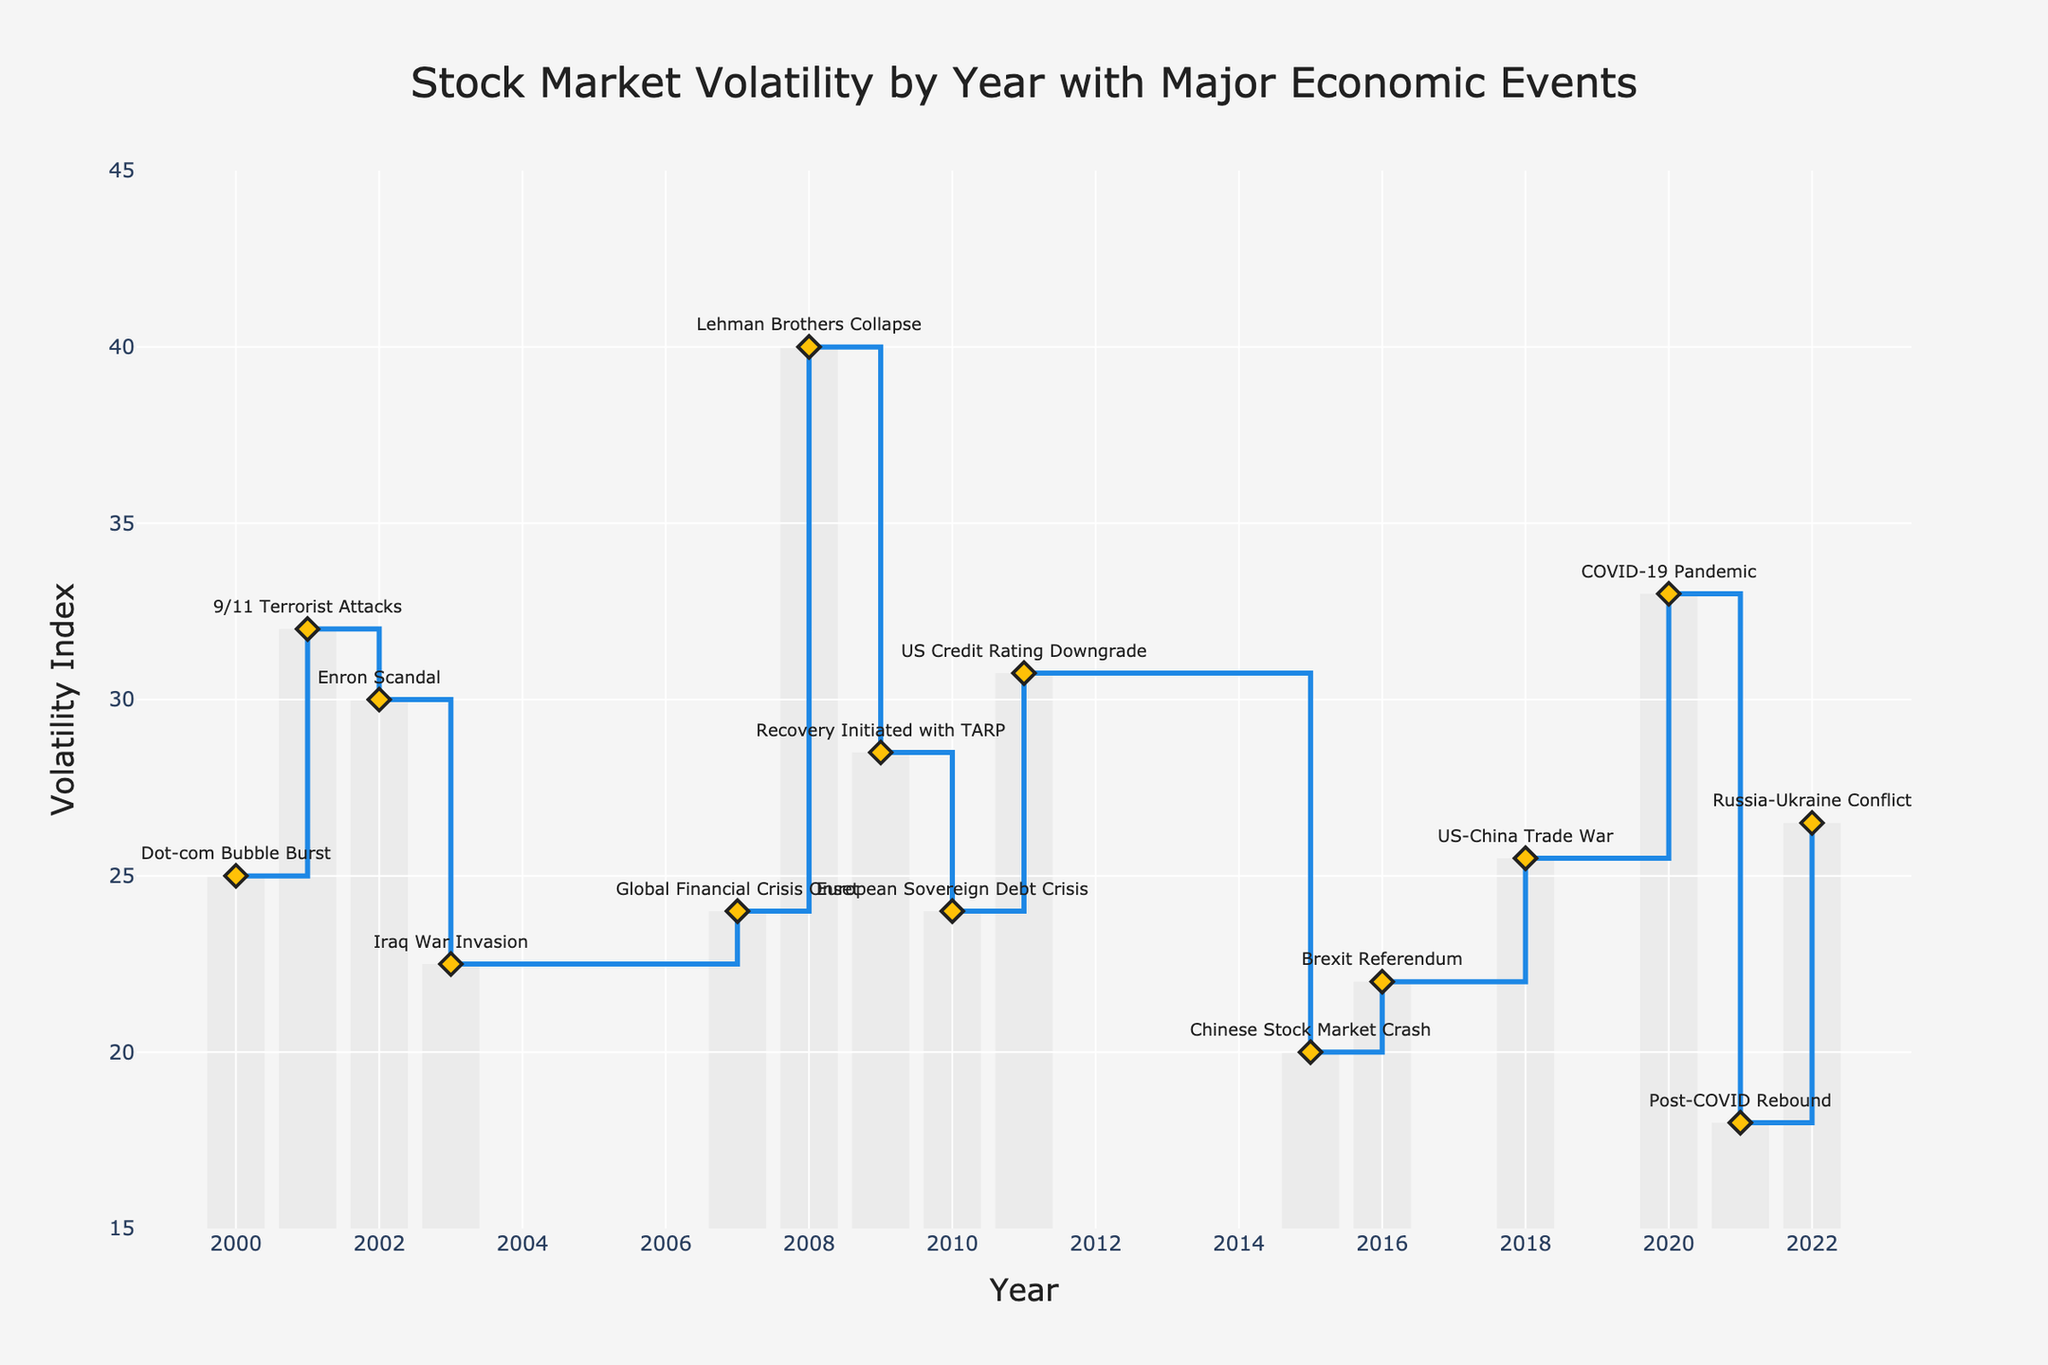what is the title of the plot? The title is typically located at the top center of the plot and provides a summary of what the visual is about. In this case, it reads "Stock Market Volatility by Year with Major Economic Events"
Answer: Stock Market Volatility by Year with Major Economic Events what is the range of the y-axis? The range of the y-axis shows the lowest and highest values that the axis can display. Here, it ranges from 15 to 45, as indicated in the y-axis settings.
Answer: 15 to 45 how many years in the plot experienced a volatility index of 25.00 or higher? To determine this, we need to count the data points where the volatility index is 25.00 or more. Identifying these points in the figure gives us the years 2000, 2001, 2002, 2007, 2008, 2009, 2011, 2018, 2020, and 2022.
Answer: 10 which year had the highest volatility, and what was the major economic event that year? By examining the plot, we can identify the year 2008 as having the highest volatility index (40.00). The major economic event associated with this year was the Lehman Brothers Collapse.
Answer: 2008, Lehman Brothers Collapse what is the average volatility index for the years following the Global Financial Crisis in 2007 up to 2022? We calculate the average by summing the volatility indices from 2008 to 2022 and then dividing by the number of years. The indices are 40.00, 28.50, 24.00, 30.75, 20.00, 22.00, 25.50, 33.00, 18.00, and 26.50, totaling 268.25, over 10 years. The average is 268.25/10 = 26.825.
Answer: 26.825 how did the stock market volatility change from 2015 to 2016? To understand the change, we compare the indices from 2015 (20.00) and 2016 (22.00). The difference is 22.00 - 20.00 = 2. This shows an increase.
Answer: Increased by 2 which major economic event corresponds to a volatility of 25.50? By checking the plot, we identify that the year 2018 saw a volatility index of 25.50, which corresponds to the US-China Trade War.
Answer: US-China Trade War how does the volatility in 2001 compare to that in 2021? Comparing the two years, 2001 has a volatility index of 32.00, while 2021 has an index of 18.00. Thus, 2001's volatility was higher.
Answer: 2001 was higher than 2021 what is the trend in volatility from 2009 to 2010? Observing the figures, the volatility index dropped from 28.50 in 2009 to 24.00 in 2010. This indicates a decreasing trend.
Answer: Decreasing trend what major event resulted in the volatility index rising above 30 after 2010? Checking the plot, the US Credit Rating Downgrade in 2011 caused the volatility index to rise to 30.75, crossing the 30 mark.
Answer: US Credit Rating Downgrade in 2011 